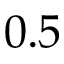Convert formula to latex. <formula><loc_0><loc_0><loc_500><loc_500>0 . 5</formula> 